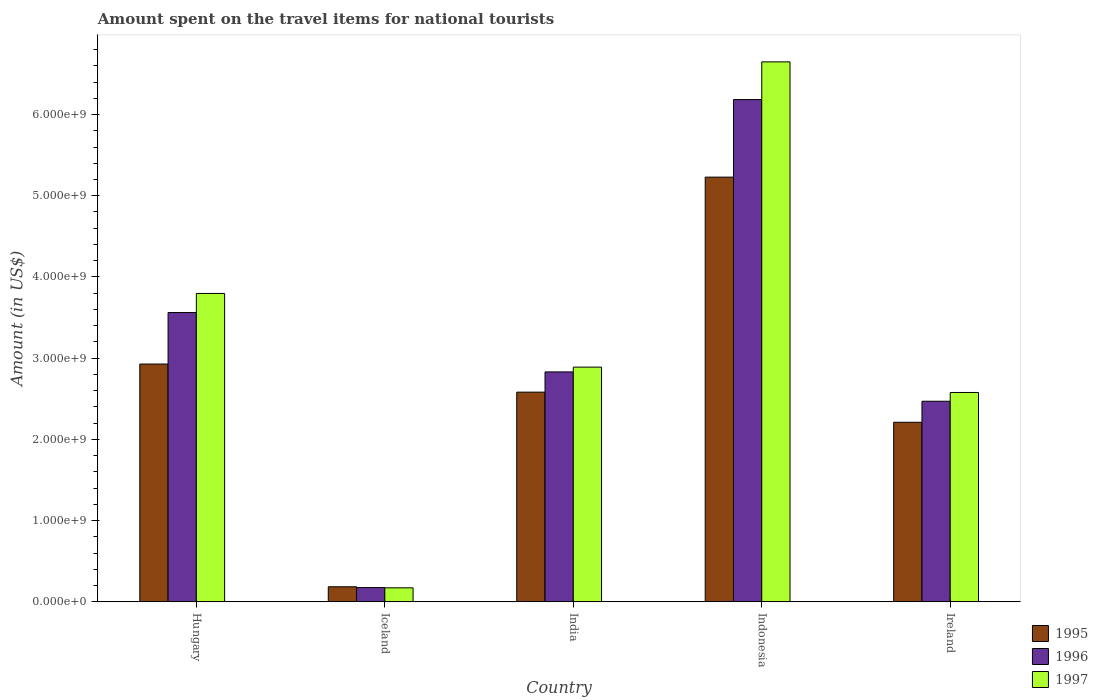How many different coloured bars are there?
Ensure brevity in your answer.  3. Are the number of bars per tick equal to the number of legend labels?
Give a very brief answer. Yes. How many bars are there on the 4th tick from the left?
Your answer should be very brief. 3. What is the amount spent on the travel items for national tourists in 1997 in Iceland?
Give a very brief answer. 1.73e+08. Across all countries, what is the maximum amount spent on the travel items for national tourists in 1995?
Offer a terse response. 5.23e+09. Across all countries, what is the minimum amount spent on the travel items for national tourists in 1997?
Offer a very short reply. 1.73e+08. In which country was the amount spent on the travel items for national tourists in 1997 maximum?
Your response must be concise. Indonesia. What is the total amount spent on the travel items for national tourists in 1997 in the graph?
Provide a short and direct response. 1.61e+1. What is the difference between the amount spent on the travel items for national tourists in 1997 in Hungary and that in Ireland?
Provide a succinct answer. 1.22e+09. What is the difference between the amount spent on the travel items for national tourists in 1996 in Iceland and the amount spent on the travel items for national tourists in 1995 in India?
Provide a short and direct response. -2.41e+09. What is the average amount spent on the travel items for national tourists in 1996 per country?
Your response must be concise. 3.04e+09. What is the difference between the amount spent on the travel items for national tourists of/in 1997 and amount spent on the travel items for national tourists of/in 1995 in Iceland?
Provide a short and direct response. -1.30e+07. What is the ratio of the amount spent on the travel items for national tourists in 1995 in Hungary to that in India?
Provide a succinct answer. 1.13. Is the amount spent on the travel items for national tourists in 1995 in Hungary less than that in Iceland?
Your response must be concise. No. Is the difference between the amount spent on the travel items for national tourists in 1997 in India and Indonesia greater than the difference between the amount spent on the travel items for national tourists in 1995 in India and Indonesia?
Offer a terse response. No. What is the difference between the highest and the second highest amount spent on the travel items for national tourists in 1995?
Keep it short and to the point. 2.30e+09. What is the difference between the highest and the lowest amount spent on the travel items for national tourists in 1996?
Provide a short and direct response. 6.01e+09. In how many countries, is the amount spent on the travel items for national tourists in 1997 greater than the average amount spent on the travel items for national tourists in 1997 taken over all countries?
Give a very brief answer. 2. Is the sum of the amount spent on the travel items for national tourists in 1996 in Hungary and Iceland greater than the maximum amount spent on the travel items for national tourists in 1995 across all countries?
Provide a short and direct response. No. How many bars are there?
Provide a short and direct response. 15. What is the difference between two consecutive major ticks on the Y-axis?
Offer a terse response. 1.00e+09. Are the values on the major ticks of Y-axis written in scientific E-notation?
Your answer should be compact. Yes. Does the graph contain any zero values?
Offer a very short reply. No. Does the graph contain grids?
Your response must be concise. No. What is the title of the graph?
Make the answer very short. Amount spent on the travel items for national tourists. Does "2001" appear as one of the legend labels in the graph?
Your answer should be compact. No. What is the label or title of the X-axis?
Your answer should be compact. Country. What is the Amount (in US$) in 1995 in Hungary?
Offer a terse response. 2.93e+09. What is the Amount (in US$) of 1996 in Hungary?
Give a very brief answer. 3.56e+09. What is the Amount (in US$) of 1997 in Hungary?
Provide a succinct answer. 3.80e+09. What is the Amount (in US$) of 1995 in Iceland?
Provide a succinct answer. 1.86e+08. What is the Amount (in US$) in 1996 in Iceland?
Your response must be concise. 1.76e+08. What is the Amount (in US$) of 1997 in Iceland?
Your response must be concise. 1.73e+08. What is the Amount (in US$) in 1995 in India?
Give a very brief answer. 2.58e+09. What is the Amount (in US$) in 1996 in India?
Keep it short and to the point. 2.83e+09. What is the Amount (in US$) in 1997 in India?
Give a very brief answer. 2.89e+09. What is the Amount (in US$) of 1995 in Indonesia?
Make the answer very short. 5.23e+09. What is the Amount (in US$) of 1996 in Indonesia?
Offer a terse response. 6.18e+09. What is the Amount (in US$) of 1997 in Indonesia?
Give a very brief answer. 6.65e+09. What is the Amount (in US$) of 1995 in Ireland?
Offer a very short reply. 2.21e+09. What is the Amount (in US$) of 1996 in Ireland?
Your answer should be very brief. 2.47e+09. What is the Amount (in US$) in 1997 in Ireland?
Ensure brevity in your answer.  2.58e+09. Across all countries, what is the maximum Amount (in US$) in 1995?
Offer a very short reply. 5.23e+09. Across all countries, what is the maximum Amount (in US$) of 1996?
Your response must be concise. 6.18e+09. Across all countries, what is the maximum Amount (in US$) in 1997?
Offer a terse response. 6.65e+09. Across all countries, what is the minimum Amount (in US$) in 1995?
Offer a terse response. 1.86e+08. Across all countries, what is the minimum Amount (in US$) of 1996?
Ensure brevity in your answer.  1.76e+08. Across all countries, what is the minimum Amount (in US$) in 1997?
Ensure brevity in your answer.  1.73e+08. What is the total Amount (in US$) of 1995 in the graph?
Provide a succinct answer. 1.31e+1. What is the total Amount (in US$) of 1996 in the graph?
Give a very brief answer. 1.52e+1. What is the total Amount (in US$) in 1997 in the graph?
Provide a short and direct response. 1.61e+1. What is the difference between the Amount (in US$) of 1995 in Hungary and that in Iceland?
Ensure brevity in your answer.  2.74e+09. What is the difference between the Amount (in US$) in 1996 in Hungary and that in Iceland?
Your answer should be very brief. 3.39e+09. What is the difference between the Amount (in US$) of 1997 in Hungary and that in Iceland?
Your answer should be very brief. 3.62e+09. What is the difference between the Amount (in US$) in 1995 in Hungary and that in India?
Give a very brief answer. 3.46e+08. What is the difference between the Amount (in US$) of 1996 in Hungary and that in India?
Offer a very short reply. 7.31e+08. What is the difference between the Amount (in US$) of 1997 in Hungary and that in India?
Your answer should be compact. 9.07e+08. What is the difference between the Amount (in US$) in 1995 in Hungary and that in Indonesia?
Give a very brief answer. -2.30e+09. What is the difference between the Amount (in US$) in 1996 in Hungary and that in Indonesia?
Offer a very short reply. -2.62e+09. What is the difference between the Amount (in US$) in 1997 in Hungary and that in Indonesia?
Provide a succinct answer. -2.85e+09. What is the difference between the Amount (in US$) of 1995 in Hungary and that in Ireland?
Make the answer very short. 7.17e+08. What is the difference between the Amount (in US$) in 1996 in Hungary and that in Ireland?
Provide a succinct answer. 1.09e+09. What is the difference between the Amount (in US$) in 1997 in Hungary and that in Ireland?
Ensure brevity in your answer.  1.22e+09. What is the difference between the Amount (in US$) of 1995 in Iceland and that in India?
Give a very brief answer. -2.40e+09. What is the difference between the Amount (in US$) of 1996 in Iceland and that in India?
Provide a short and direct response. -2.66e+09. What is the difference between the Amount (in US$) in 1997 in Iceland and that in India?
Provide a succinct answer. -2.72e+09. What is the difference between the Amount (in US$) of 1995 in Iceland and that in Indonesia?
Keep it short and to the point. -5.04e+09. What is the difference between the Amount (in US$) in 1996 in Iceland and that in Indonesia?
Your answer should be compact. -6.01e+09. What is the difference between the Amount (in US$) of 1997 in Iceland and that in Indonesia?
Your answer should be very brief. -6.48e+09. What is the difference between the Amount (in US$) of 1995 in Iceland and that in Ireland?
Give a very brief answer. -2.02e+09. What is the difference between the Amount (in US$) in 1996 in Iceland and that in Ireland?
Your response must be concise. -2.29e+09. What is the difference between the Amount (in US$) of 1997 in Iceland and that in Ireland?
Keep it short and to the point. -2.40e+09. What is the difference between the Amount (in US$) in 1995 in India and that in Indonesia?
Keep it short and to the point. -2.65e+09. What is the difference between the Amount (in US$) in 1996 in India and that in Indonesia?
Provide a short and direct response. -3.35e+09. What is the difference between the Amount (in US$) of 1997 in India and that in Indonesia?
Provide a succinct answer. -3.76e+09. What is the difference between the Amount (in US$) in 1995 in India and that in Ireland?
Your answer should be compact. 3.71e+08. What is the difference between the Amount (in US$) in 1996 in India and that in Ireland?
Offer a very short reply. 3.61e+08. What is the difference between the Amount (in US$) of 1997 in India and that in Ireland?
Give a very brief answer. 3.12e+08. What is the difference between the Amount (in US$) in 1995 in Indonesia and that in Ireland?
Offer a terse response. 3.02e+09. What is the difference between the Amount (in US$) in 1996 in Indonesia and that in Ireland?
Your response must be concise. 3.71e+09. What is the difference between the Amount (in US$) of 1997 in Indonesia and that in Ireland?
Ensure brevity in your answer.  4.07e+09. What is the difference between the Amount (in US$) in 1995 in Hungary and the Amount (in US$) in 1996 in Iceland?
Offer a terse response. 2.75e+09. What is the difference between the Amount (in US$) of 1995 in Hungary and the Amount (in US$) of 1997 in Iceland?
Give a very brief answer. 2.76e+09. What is the difference between the Amount (in US$) in 1996 in Hungary and the Amount (in US$) in 1997 in Iceland?
Make the answer very short. 3.39e+09. What is the difference between the Amount (in US$) of 1995 in Hungary and the Amount (in US$) of 1996 in India?
Provide a succinct answer. 9.70e+07. What is the difference between the Amount (in US$) of 1995 in Hungary and the Amount (in US$) of 1997 in India?
Provide a short and direct response. 3.80e+07. What is the difference between the Amount (in US$) of 1996 in Hungary and the Amount (in US$) of 1997 in India?
Provide a succinct answer. 6.72e+08. What is the difference between the Amount (in US$) of 1995 in Hungary and the Amount (in US$) of 1996 in Indonesia?
Ensure brevity in your answer.  -3.26e+09. What is the difference between the Amount (in US$) of 1995 in Hungary and the Amount (in US$) of 1997 in Indonesia?
Your answer should be compact. -3.72e+09. What is the difference between the Amount (in US$) of 1996 in Hungary and the Amount (in US$) of 1997 in Indonesia?
Provide a succinct answer. -3.09e+09. What is the difference between the Amount (in US$) in 1995 in Hungary and the Amount (in US$) in 1996 in Ireland?
Keep it short and to the point. 4.58e+08. What is the difference between the Amount (in US$) in 1995 in Hungary and the Amount (in US$) in 1997 in Ireland?
Ensure brevity in your answer.  3.50e+08. What is the difference between the Amount (in US$) of 1996 in Hungary and the Amount (in US$) of 1997 in Ireland?
Provide a short and direct response. 9.84e+08. What is the difference between the Amount (in US$) of 1995 in Iceland and the Amount (in US$) of 1996 in India?
Provide a succinct answer. -2.64e+09. What is the difference between the Amount (in US$) in 1995 in Iceland and the Amount (in US$) in 1997 in India?
Keep it short and to the point. -2.70e+09. What is the difference between the Amount (in US$) in 1996 in Iceland and the Amount (in US$) in 1997 in India?
Offer a terse response. -2.71e+09. What is the difference between the Amount (in US$) in 1995 in Iceland and the Amount (in US$) in 1996 in Indonesia?
Provide a succinct answer. -6.00e+09. What is the difference between the Amount (in US$) of 1995 in Iceland and the Amount (in US$) of 1997 in Indonesia?
Provide a short and direct response. -6.46e+09. What is the difference between the Amount (in US$) in 1996 in Iceland and the Amount (in US$) in 1997 in Indonesia?
Provide a succinct answer. -6.47e+09. What is the difference between the Amount (in US$) in 1995 in Iceland and the Amount (in US$) in 1996 in Ireland?
Ensure brevity in your answer.  -2.28e+09. What is the difference between the Amount (in US$) in 1995 in Iceland and the Amount (in US$) in 1997 in Ireland?
Your response must be concise. -2.39e+09. What is the difference between the Amount (in US$) of 1996 in Iceland and the Amount (in US$) of 1997 in Ireland?
Your answer should be compact. -2.40e+09. What is the difference between the Amount (in US$) of 1995 in India and the Amount (in US$) of 1996 in Indonesia?
Your answer should be very brief. -3.60e+09. What is the difference between the Amount (in US$) in 1995 in India and the Amount (in US$) in 1997 in Indonesia?
Your answer should be very brief. -4.07e+09. What is the difference between the Amount (in US$) in 1996 in India and the Amount (in US$) in 1997 in Indonesia?
Offer a terse response. -3.82e+09. What is the difference between the Amount (in US$) in 1995 in India and the Amount (in US$) in 1996 in Ireland?
Your response must be concise. 1.12e+08. What is the difference between the Amount (in US$) in 1996 in India and the Amount (in US$) in 1997 in Ireland?
Provide a succinct answer. 2.53e+08. What is the difference between the Amount (in US$) of 1995 in Indonesia and the Amount (in US$) of 1996 in Ireland?
Ensure brevity in your answer.  2.76e+09. What is the difference between the Amount (in US$) in 1995 in Indonesia and the Amount (in US$) in 1997 in Ireland?
Make the answer very short. 2.65e+09. What is the difference between the Amount (in US$) in 1996 in Indonesia and the Amount (in US$) in 1997 in Ireland?
Offer a very short reply. 3.61e+09. What is the average Amount (in US$) in 1995 per country?
Provide a short and direct response. 2.63e+09. What is the average Amount (in US$) of 1996 per country?
Ensure brevity in your answer.  3.04e+09. What is the average Amount (in US$) in 1997 per country?
Offer a very short reply. 3.22e+09. What is the difference between the Amount (in US$) of 1995 and Amount (in US$) of 1996 in Hungary?
Your response must be concise. -6.34e+08. What is the difference between the Amount (in US$) of 1995 and Amount (in US$) of 1997 in Hungary?
Your answer should be very brief. -8.69e+08. What is the difference between the Amount (in US$) of 1996 and Amount (in US$) of 1997 in Hungary?
Your answer should be compact. -2.35e+08. What is the difference between the Amount (in US$) in 1995 and Amount (in US$) in 1997 in Iceland?
Keep it short and to the point. 1.30e+07. What is the difference between the Amount (in US$) of 1995 and Amount (in US$) of 1996 in India?
Give a very brief answer. -2.49e+08. What is the difference between the Amount (in US$) of 1995 and Amount (in US$) of 1997 in India?
Offer a terse response. -3.08e+08. What is the difference between the Amount (in US$) in 1996 and Amount (in US$) in 1997 in India?
Offer a terse response. -5.90e+07. What is the difference between the Amount (in US$) in 1995 and Amount (in US$) in 1996 in Indonesia?
Your response must be concise. -9.55e+08. What is the difference between the Amount (in US$) in 1995 and Amount (in US$) in 1997 in Indonesia?
Give a very brief answer. -1.42e+09. What is the difference between the Amount (in US$) in 1996 and Amount (in US$) in 1997 in Indonesia?
Your answer should be very brief. -4.64e+08. What is the difference between the Amount (in US$) of 1995 and Amount (in US$) of 1996 in Ireland?
Your answer should be compact. -2.59e+08. What is the difference between the Amount (in US$) in 1995 and Amount (in US$) in 1997 in Ireland?
Your response must be concise. -3.67e+08. What is the difference between the Amount (in US$) in 1996 and Amount (in US$) in 1997 in Ireland?
Offer a very short reply. -1.08e+08. What is the ratio of the Amount (in US$) in 1995 in Hungary to that in Iceland?
Provide a short and direct response. 15.74. What is the ratio of the Amount (in US$) in 1996 in Hungary to that in Iceland?
Give a very brief answer. 20.24. What is the ratio of the Amount (in US$) in 1997 in Hungary to that in Iceland?
Your answer should be very brief. 21.95. What is the ratio of the Amount (in US$) in 1995 in Hungary to that in India?
Provide a short and direct response. 1.13. What is the ratio of the Amount (in US$) in 1996 in Hungary to that in India?
Ensure brevity in your answer.  1.26. What is the ratio of the Amount (in US$) in 1997 in Hungary to that in India?
Offer a very short reply. 1.31. What is the ratio of the Amount (in US$) of 1995 in Hungary to that in Indonesia?
Offer a very short reply. 0.56. What is the ratio of the Amount (in US$) in 1996 in Hungary to that in Indonesia?
Provide a succinct answer. 0.58. What is the ratio of the Amount (in US$) of 1997 in Hungary to that in Indonesia?
Ensure brevity in your answer.  0.57. What is the ratio of the Amount (in US$) in 1995 in Hungary to that in Ireland?
Ensure brevity in your answer.  1.32. What is the ratio of the Amount (in US$) of 1996 in Hungary to that in Ireland?
Provide a short and direct response. 1.44. What is the ratio of the Amount (in US$) in 1997 in Hungary to that in Ireland?
Offer a very short reply. 1.47. What is the ratio of the Amount (in US$) in 1995 in Iceland to that in India?
Offer a very short reply. 0.07. What is the ratio of the Amount (in US$) of 1996 in Iceland to that in India?
Your answer should be very brief. 0.06. What is the ratio of the Amount (in US$) in 1997 in Iceland to that in India?
Offer a terse response. 0.06. What is the ratio of the Amount (in US$) of 1995 in Iceland to that in Indonesia?
Make the answer very short. 0.04. What is the ratio of the Amount (in US$) in 1996 in Iceland to that in Indonesia?
Provide a succinct answer. 0.03. What is the ratio of the Amount (in US$) of 1997 in Iceland to that in Indonesia?
Keep it short and to the point. 0.03. What is the ratio of the Amount (in US$) in 1995 in Iceland to that in Ireland?
Make the answer very short. 0.08. What is the ratio of the Amount (in US$) in 1996 in Iceland to that in Ireland?
Your answer should be compact. 0.07. What is the ratio of the Amount (in US$) of 1997 in Iceland to that in Ireland?
Ensure brevity in your answer.  0.07. What is the ratio of the Amount (in US$) in 1995 in India to that in Indonesia?
Your answer should be very brief. 0.49. What is the ratio of the Amount (in US$) in 1996 in India to that in Indonesia?
Give a very brief answer. 0.46. What is the ratio of the Amount (in US$) of 1997 in India to that in Indonesia?
Provide a short and direct response. 0.43. What is the ratio of the Amount (in US$) in 1995 in India to that in Ireland?
Provide a short and direct response. 1.17. What is the ratio of the Amount (in US$) of 1996 in India to that in Ireland?
Your answer should be very brief. 1.15. What is the ratio of the Amount (in US$) of 1997 in India to that in Ireland?
Give a very brief answer. 1.12. What is the ratio of the Amount (in US$) of 1995 in Indonesia to that in Ireland?
Your answer should be compact. 2.37. What is the ratio of the Amount (in US$) of 1996 in Indonesia to that in Ireland?
Offer a terse response. 2.5. What is the ratio of the Amount (in US$) in 1997 in Indonesia to that in Ireland?
Ensure brevity in your answer.  2.58. What is the difference between the highest and the second highest Amount (in US$) of 1995?
Offer a very short reply. 2.30e+09. What is the difference between the highest and the second highest Amount (in US$) of 1996?
Offer a very short reply. 2.62e+09. What is the difference between the highest and the second highest Amount (in US$) in 1997?
Ensure brevity in your answer.  2.85e+09. What is the difference between the highest and the lowest Amount (in US$) in 1995?
Your answer should be compact. 5.04e+09. What is the difference between the highest and the lowest Amount (in US$) in 1996?
Ensure brevity in your answer.  6.01e+09. What is the difference between the highest and the lowest Amount (in US$) in 1997?
Offer a very short reply. 6.48e+09. 